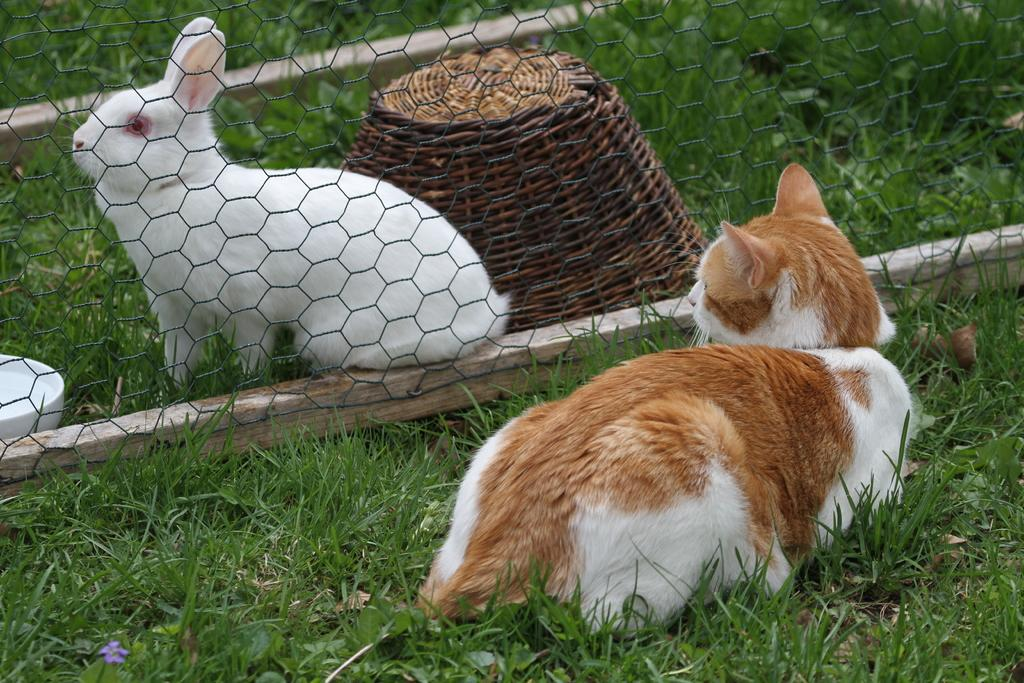What type of animal is behind the fence in the image? There is a rabbit behind the fence in the image. What other animal can be seen in the image? There is a cat sitting at the right side in the image. What type of vegetation is present on the floor in the image? There is grass on the floor in the image. What type of bag is the rat carrying in the image? There is no rat or bag present in the image. 